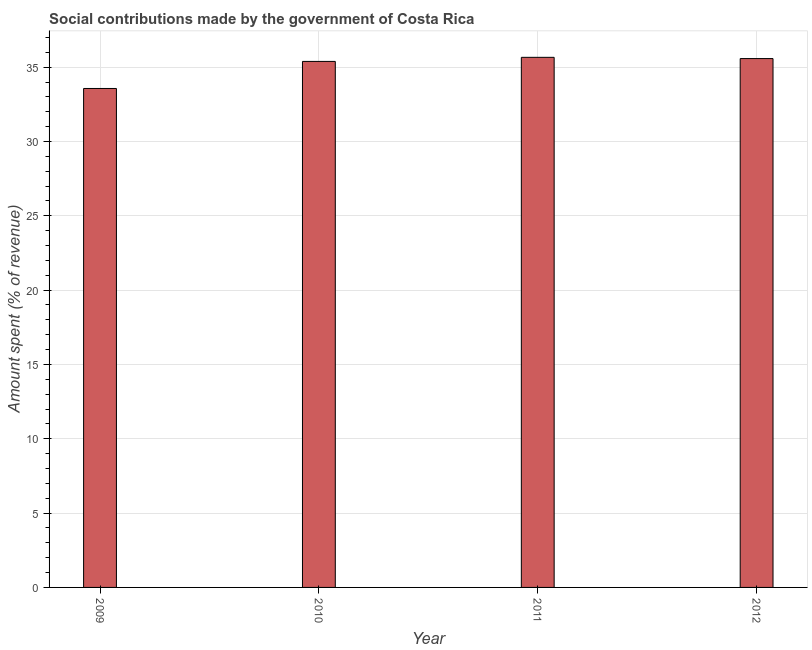Does the graph contain grids?
Provide a succinct answer. Yes. What is the title of the graph?
Provide a succinct answer. Social contributions made by the government of Costa Rica. What is the label or title of the X-axis?
Offer a very short reply. Year. What is the label or title of the Y-axis?
Provide a short and direct response. Amount spent (% of revenue). What is the amount spent in making social contributions in 2010?
Keep it short and to the point. 35.39. Across all years, what is the maximum amount spent in making social contributions?
Your answer should be very brief. 35.66. Across all years, what is the minimum amount spent in making social contributions?
Ensure brevity in your answer.  33.57. What is the sum of the amount spent in making social contributions?
Make the answer very short. 140.19. What is the difference between the amount spent in making social contributions in 2009 and 2011?
Give a very brief answer. -2.1. What is the average amount spent in making social contributions per year?
Your answer should be very brief. 35.05. What is the median amount spent in making social contributions?
Make the answer very short. 35.48. In how many years, is the amount spent in making social contributions greater than 5 %?
Ensure brevity in your answer.  4. Do a majority of the years between 2011 and 2012 (inclusive) have amount spent in making social contributions greater than 13 %?
Offer a very short reply. Yes. What is the ratio of the amount spent in making social contributions in 2011 to that in 2012?
Your answer should be compact. 1. What is the difference between the highest and the second highest amount spent in making social contributions?
Your response must be concise. 0.08. Is the sum of the amount spent in making social contributions in 2009 and 2011 greater than the maximum amount spent in making social contributions across all years?
Your response must be concise. Yes. Are all the bars in the graph horizontal?
Offer a terse response. No. How many years are there in the graph?
Offer a terse response. 4. What is the difference between two consecutive major ticks on the Y-axis?
Provide a succinct answer. 5. What is the Amount spent (% of revenue) in 2009?
Keep it short and to the point. 33.57. What is the Amount spent (% of revenue) in 2010?
Offer a terse response. 35.39. What is the Amount spent (% of revenue) of 2011?
Your answer should be very brief. 35.66. What is the Amount spent (% of revenue) of 2012?
Ensure brevity in your answer.  35.58. What is the difference between the Amount spent (% of revenue) in 2009 and 2010?
Offer a very short reply. -1.82. What is the difference between the Amount spent (% of revenue) in 2009 and 2011?
Your answer should be very brief. -2.1. What is the difference between the Amount spent (% of revenue) in 2009 and 2012?
Ensure brevity in your answer.  -2.01. What is the difference between the Amount spent (% of revenue) in 2010 and 2011?
Your answer should be very brief. -0.27. What is the difference between the Amount spent (% of revenue) in 2010 and 2012?
Keep it short and to the point. -0.19. What is the difference between the Amount spent (% of revenue) in 2011 and 2012?
Your response must be concise. 0.08. What is the ratio of the Amount spent (% of revenue) in 2009 to that in 2010?
Provide a short and direct response. 0.95. What is the ratio of the Amount spent (% of revenue) in 2009 to that in 2011?
Your answer should be compact. 0.94. What is the ratio of the Amount spent (% of revenue) in 2009 to that in 2012?
Make the answer very short. 0.94. What is the ratio of the Amount spent (% of revenue) in 2010 to that in 2011?
Your answer should be very brief. 0.99. What is the ratio of the Amount spent (% of revenue) in 2010 to that in 2012?
Provide a short and direct response. 0.99. 